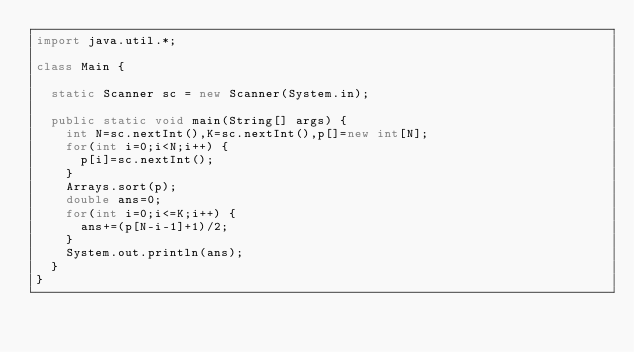Convert code to text. <code><loc_0><loc_0><loc_500><loc_500><_Java_>import java.util.*;

class Main {

	static Scanner sc = new Scanner(System.in);

	public static void main(String[] args) {
		int N=sc.nextInt(),K=sc.nextInt(),p[]=new int[N];
		for(int i=0;i<N;i++) {
			p[i]=sc.nextInt();
		}
		Arrays.sort(p);
		double ans=0;
		for(int i=0;i<=K;i++) {
			ans+=(p[N-i-1]+1)/2;
		}
		System.out.println(ans);
	}
}</code> 